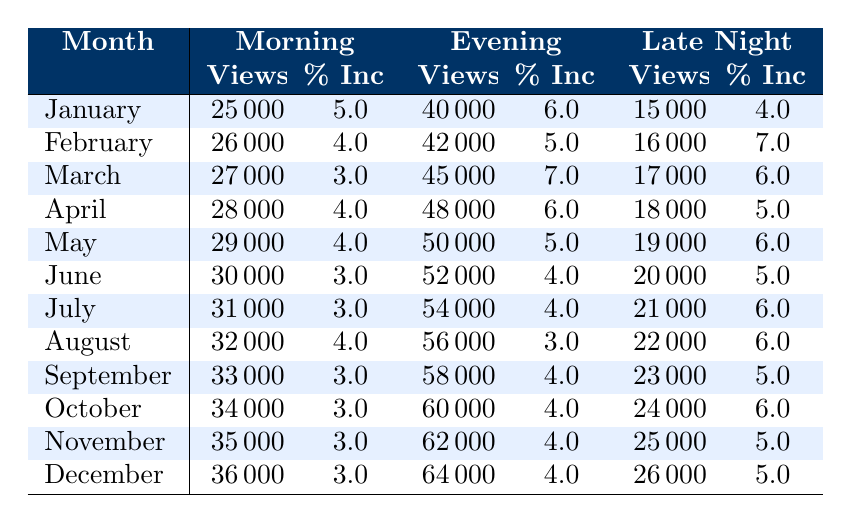What was the viewership for the Evening segment in December? The table shows that the viewership for the Evening segment in December is listed under the column "Evening" in the respective row for December. It indicates a viewership of 64000.
Answer: 64000 Which month had the highest viewership in the Late Night segment? To find the highest Late Night viewership, we compare the values in the Late Night column for each month. December shows 26000, which is higher than the other months.
Answer: December What is the percentage increase in the Morning segment from January to February? The January viewership for the Morning segment is 25000, and in February, it is 26000. The percentage increase is calculated as ((26000 - 25000) / 25000) * 100 = 4%.
Answer: 4% Was there an increase in the viewership of the Evening segment from April to May? In April, the viewership for the Evening segment was 48000, and in May, it increased to 50000. Since 50000 is greater than 48000, this confirms an increase.
Answer: Yes What is the average viewership for the Late Night segment over all months? First, we sum the viewerships for the Late Night segment from January (15000), February (16000), March (17000), April (18000), May (19000), June (20000), July (21000), August (22000), September (23000), October (24000), November (25000), and December (26000). The total is 186000. Dividing by the number of months (12) gives an average of 15500.
Answer: 21500 Which segment had the highest increase percentage in February? Checking the Increase Percentage column for February, the Morning segment had a 4% increase, the Evening segment had a 5% increase, and the Late Night segment had a 7% increase. The Late Night segment has the highest percentage.
Answer: Late Night In which month did the Late Night segment see the smallest percentage increase? Reviewing the percentage increases for the Late Night segment, January shows 4%, February is 7%, March is 6%, April is 5%, May is 6%, June is 5%, July is 6%, August is 6%, September is 5%, October is 6%, November is 5%, and December is 5%. The smallest increase of 4% occurred in January.
Answer: January What was the total viewership increase in May compared to March across all segments? For May, the Morning segment had 29000, Evening 50000, and Late Night 19000, while March had 27000, 45000, and 17000 respectively. The differences are 2000 (Morning), 5000 (Evening), and 2000 (Late Night), summing these gives a total increase of 9000.
Answer: 9000 Which month had the lowest overall viewership across all segments? The total viewership can be calculated for each month by summing the three segments. January totals 40000 + 25000 + 15000 = 100000. February totals 26000 + 42000 + 16000 = 84000. Continuing this method shows that February has the lowest total of 84000.
Answer: February 